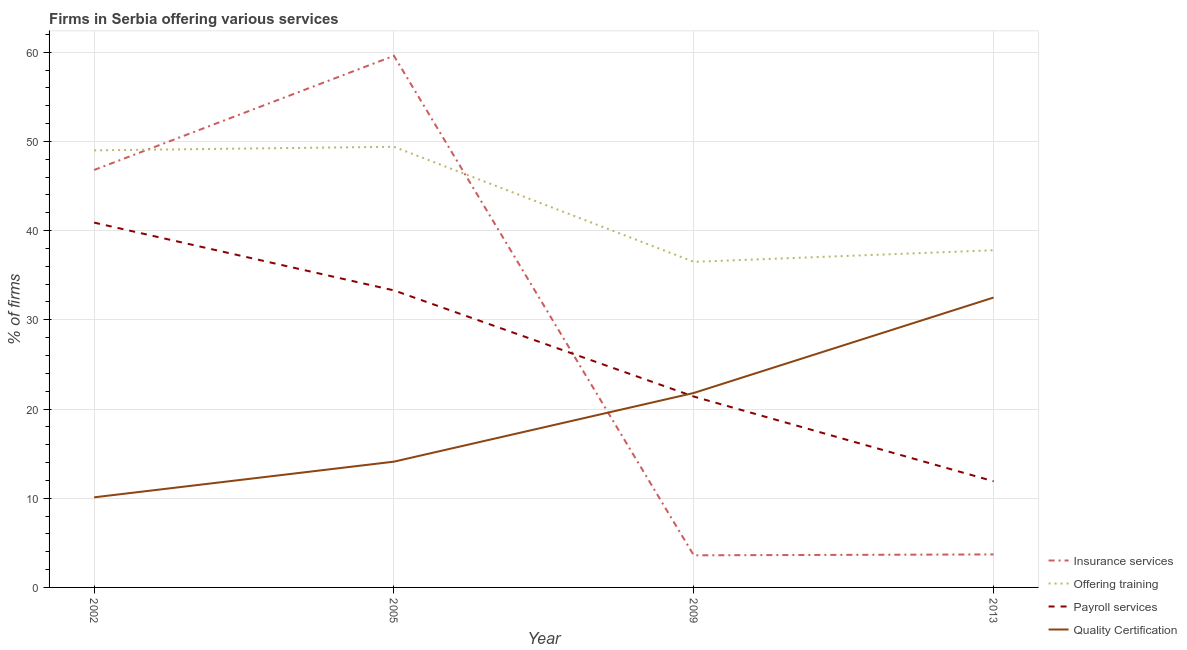Does the line corresponding to percentage of firms offering training intersect with the line corresponding to percentage of firms offering quality certification?
Make the answer very short. No. Across all years, what is the maximum percentage of firms offering training?
Your response must be concise. 49.4. In which year was the percentage of firms offering quality certification maximum?
Make the answer very short. 2013. What is the total percentage of firms offering insurance services in the graph?
Your answer should be very brief. 113.7. What is the difference between the percentage of firms offering insurance services in 2009 and that in 2013?
Your response must be concise. -0.1. What is the difference between the percentage of firms offering training in 2002 and the percentage of firms offering insurance services in 2013?
Keep it short and to the point. 45.3. What is the average percentage of firms offering quality certification per year?
Keep it short and to the point. 19.62. In the year 2002, what is the difference between the percentage of firms offering payroll services and percentage of firms offering training?
Offer a terse response. -8.1. In how many years, is the percentage of firms offering payroll services greater than 58 %?
Your answer should be compact. 0. What is the ratio of the percentage of firms offering insurance services in 2009 to that in 2013?
Offer a very short reply. 0.97. Is the percentage of firms offering insurance services in 2002 less than that in 2013?
Offer a terse response. No. What is the difference between the highest and the second highest percentage of firms offering insurance services?
Keep it short and to the point. 12.8. In how many years, is the percentage of firms offering training greater than the average percentage of firms offering training taken over all years?
Provide a short and direct response. 2. Is the sum of the percentage of firms offering payroll services in 2009 and 2013 greater than the maximum percentage of firms offering training across all years?
Provide a short and direct response. No. Is it the case that in every year, the sum of the percentage of firms offering insurance services and percentage of firms offering training is greater than the percentage of firms offering payroll services?
Offer a terse response. Yes. Is the percentage of firms offering training strictly greater than the percentage of firms offering payroll services over the years?
Ensure brevity in your answer.  Yes. Is the percentage of firms offering payroll services strictly less than the percentage of firms offering training over the years?
Make the answer very short. Yes. Are the values on the major ticks of Y-axis written in scientific E-notation?
Provide a short and direct response. No. Does the graph contain any zero values?
Offer a terse response. No. Where does the legend appear in the graph?
Ensure brevity in your answer.  Bottom right. How many legend labels are there?
Keep it short and to the point. 4. What is the title of the graph?
Offer a very short reply. Firms in Serbia offering various services . What is the label or title of the X-axis?
Provide a short and direct response. Year. What is the label or title of the Y-axis?
Keep it short and to the point. % of firms. What is the % of firms of Insurance services in 2002?
Offer a terse response. 46.8. What is the % of firms of Offering training in 2002?
Ensure brevity in your answer.  49. What is the % of firms of Payroll services in 2002?
Provide a succinct answer. 40.9. What is the % of firms of Quality Certification in 2002?
Ensure brevity in your answer.  10.1. What is the % of firms of Insurance services in 2005?
Give a very brief answer. 59.6. What is the % of firms of Offering training in 2005?
Make the answer very short. 49.4. What is the % of firms of Payroll services in 2005?
Ensure brevity in your answer.  33.3. What is the % of firms in Quality Certification in 2005?
Make the answer very short. 14.1. What is the % of firms of Insurance services in 2009?
Offer a terse response. 3.6. What is the % of firms of Offering training in 2009?
Your response must be concise. 36.5. What is the % of firms in Payroll services in 2009?
Provide a short and direct response. 21.4. What is the % of firms in Quality Certification in 2009?
Keep it short and to the point. 21.8. What is the % of firms in Insurance services in 2013?
Your answer should be compact. 3.7. What is the % of firms in Offering training in 2013?
Ensure brevity in your answer.  37.8. What is the % of firms of Quality Certification in 2013?
Offer a terse response. 32.5. Across all years, what is the maximum % of firms in Insurance services?
Keep it short and to the point. 59.6. Across all years, what is the maximum % of firms in Offering training?
Make the answer very short. 49.4. Across all years, what is the maximum % of firms of Payroll services?
Your answer should be very brief. 40.9. Across all years, what is the maximum % of firms of Quality Certification?
Offer a very short reply. 32.5. Across all years, what is the minimum % of firms in Insurance services?
Make the answer very short. 3.6. Across all years, what is the minimum % of firms of Offering training?
Keep it short and to the point. 36.5. Across all years, what is the minimum % of firms of Payroll services?
Your answer should be very brief. 11.9. What is the total % of firms of Insurance services in the graph?
Your response must be concise. 113.7. What is the total % of firms of Offering training in the graph?
Keep it short and to the point. 172.7. What is the total % of firms of Payroll services in the graph?
Your answer should be compact. 107.5. What is the total % of firms of Quality Certification in the graph?
Make the answer very short. 78.5. What is the difference between the % of firms in Insurance services in 2002 and that in 2005?
Offer a very short reply. -12.8. What is the difference between the % of firms of Payroll services in 2002 and that in 2005?
Provide a short and direct response. 7.6. What is the difference between the % of firms in Quality Certification in 2002 and that in 2005?
Your answer should be compact. -4. What is the difference between the % of firms of Insurance services in 2002 and that in 2009?
Your answer should be very brief. 43.2. What is the difference between the % of firms of Payroll services in 2002 and that in 2009?
Offer a terse response. 19.5. What is the difference between the % of firms of Insurance services in 2002 and that in 2013?
Your response must be concise. 43.1. What is the difference between the % of firms in Offering training in 2002 and that in 2013?
Give a very brief answer. 11.2. What is the difference between the % of firms in Quality Certification in 2002 and that in 2013?
Offer a very short reply. -22.4. What is the difference between the % of firms of Insurance services in 2005 and that in 2009?
Keep it short and to the point. 56. What is the difference between the % of firms of Insurance services in 2005 and that in 2013?
Make the answer very short. 55.9. What is the difference between the % of firms in Offering training in 2005 and that in 2013?
Keep it short and to the point. 11.6. What is the difference between the % of firms in Payroll services in 2005 and that in 2013?
Offer a very short reply. 21.4. What is the difference between the % of firms of Quality Certification in 2005 and that in 2013?
Ensure brevity in your answer.  -18.4. What is the difference between the % of firms in Offering training in 2009 and that in 2013?
Offer a terse response. -1.3. What is the difference between the % of firms in Insurance services in 2002 and the % of firms in Offering training in 2005?
Provide a succinct answer. -2.6. What is the difference between the % of firms in Insurance services in 2002 and the % of firms in Payroll services in 2005?
Offer a very short reply. 13.5. What is the difference between the % of firms of Insurance services in 2002 and the % of firms of Quality Certification in 2005?
Your answer should be very brief. 32.7. What is the difference between the % of firms of Offering training in 2002 and the % of firms of Quality Certification in 2005?
Ensure brevity in your answer.  34.9. What is the difference between the % of firms of Payroll services in 2002 and the % of firms of Quality Certification in 2005?
Give a very brief answer. 26.8. What is the difference between the % of firms in Insurance services in 2002 and the % of firms in Payroll services in 2009?
Your answer should be compact. 25.4. What is the difference between the % of firms in Insurance services in 2002 and the % of firms in Quality Certification in 2009?
Provide a short and direct response. 25. What is the difference between the % of firms in Offering training in 2002 and the % of firms in Payroll services in 2009?
Give a very brief answer. 27.6. What is the difference between the % of firms of Offering training in 2002 and the % of firms of Quality Certification in 2009?
Provide a short and direct response. 27.2. What is the difference between the % of firms of Insurance services in 2002 and the % of firms of Payroll services in 2013?
Keep it short and to the point. 34.9. What is the difference between the % of firms in Offering training in 2002 and the % of firms in Payroll services in 2013?
Ensure brevity in your answer.  37.1. What is the difference between the % of firms of Offering training in 2002 and the % of firms of Quality Certification in 2013?
Make the answer very short. 16.5. What is the difference between the % of firms of Payroll services in 2002 and the % of firms of Quality Certification in 2013?
Provide a short and direct response. 8.4. What is the difference between the % of firms of Insurance services in 2005 and the % of firms of Offering training in 2009?
Your response must be concise. 23.1. What is the difference between the % of firms in Insurance services in 2005 and the % of firms in Payroll services in 2009?
Ensure brevity in your answer.  38.2. What is the difference between the % of firms of Insurance services in 2005 and the % of firms of Quality Certification in 2009?
Offer a very short reply. 37.8. What is the difference between the % of firms of Offering training in 2005 and the % of firms of Payroll services in 2009?
Provide a short and direct response. 28. What is the difference between the % of firms in Offering training in 2005 and the % of firms in Quality Certification in 2009?
Ensure brevity in your answer.  27.6. What is the difference between the % of firms of Insurance services in 2005 and the % of firms of Offering training in 2013?
Keep it short and to the point. 21.8. What is the difference between the % of firms in Insurance services in 2005 and the % of firms in Payroll services in 2013?
Ensure brevity in your answer.  47.7. What is the difference between the % of firms in Insurance services in 2005 and the % of firms in Quality Certification in 2013?
Provide a succinct answer. 27.1. What is the difference between the % of firms in Offering training in 2005 and the % of firms in Payroll services in 2013?
Offer a very short reply. 37.5. What is the difference between the % of firms in Insurance services in 2009 and the % of firms in Offering training in 2013?
Your response must be concise. -34.2. What is the difference between the % of firms in Insurance services in 2009 and the % of firms in Payroll services in 2013?
Keep it short and to the point. -8.3. What is the difference between the % of firms of Insurance services in 2009 and the % of firms of Quality Certification in 2013?
Offer a very short reply. -28.9. What is the difference between the % of firms in Offering training in 2009 and the % of firms in Payroll services in 2013?
Ensure brevity in your answer.  24.6. What is the difference between the % of firms of Payroll services in 2009 and the % of firms of Quality Certification in 2013?
Provide a short and direct response. -11.1. What is the average % of firms in Insurance services per year?
Make the answer very short. 28.43. What is the average % of firms of Offering training per year?
Keep it short and to the point. 43.17. What is the average % of firms in Payroll services per year?
Ensure brevity in your answer.  26.88. What is the average % of firms of Quality Certification per year?
Provide a succinct answer. 19.62. In the year 2002, what is the difference between the % of firms of Insurance services and % of firms of Offering training?
Ensure brevity in your answer.  -2.2. In the year 2002, what is the difference between the % of firms of Insurance services and % of firms of Payroll services?
Give a very brief answer. 5.9. In the year 2002, what is the difference between the % of firms in Insurance services and % of firms in Quality Certification?
Ensure brevity in your answer.  36.7. In the year 2002, what is the difference between the % of firms in Offering training and % of firms in Quality Certification?
Your response must be concise. 38.9. In the year 2002, what is the difference between the % of firms in Payroll services and % of firms in Quality Certification?
Give a very brief answer. 30.8. In the year 2005, what is the difference between the % of firms of Insurance services and % of firms of Offering training?
Make the answer very short. 10.2. In the year 2005, what is the difference between the % of firms in Insurance services and % of firms in Payroll services?
Your response must be concise. 26.3. In the year 2005, what is the difference between the % of firms of Insurance services and % of firms of Quality Certification?
Offer a very short reply. 45.5. In the year 2005, what is the difference between the % of firms in Offering training and % of firms in Payroll services?
Give a very brief answer. 16.1. In the year 2005, what is the difference between the % of firms of Offering training and % of firms of Quality Certification?
Offer a terse response. 35.3. In the year 2009, what is the difference between the % of firms of Insurance services and % of firms of Offering training?
Provide a succinct answer. -32.9. In the year 2009, what is the difference between the % of firms of Insurance services and % of firms of Payroll services?
Your response must be concise. -17.8. In the year 2009, what is the difference between the % of firms in Insurance services and % of firms in Quality Certification?
Keep it short and to the point. -18.2. In the year 2009, what is the difference between the % of firms of Offering training and % of firms of Payroll services?
Give a very brief answer. 15.1. In the year 2013, what is the difference between the % of firms of Insurance services and % of firms of Offering training?
Offer a very short reply. -34.1. In the year 2013, what is the difference between the % of firms of Insurance services and % of firms of Payroll services?
Offer a very short reply. -8.2. In the year 2013, what is the difference between the % of firms in Insurance services and % of firms in Quality Certification?
Make the answer very short. -28.8. In the year 2013, what is the difference between the % of firms of Offering training and % of firms of Payroll services?
Provide a short and direct response. 25.9. In the year 2013, what is the difference between the % of firms in Offering training and % of firms in Quality Certification?
Offer a very short reply. 5.3. In the year 2013, what is the difference between the % of firms in Payroll services and % of firms in Quality Certification?
Make the answer very short. -20.6. What is the ratio of the % of firms in Insurance services in 2002 to that in 2005?
Offer a terse response. 0.79. What is the ratio of the % of firms in Offering training in 2002 to that in 2005?
Your answer should be compact. 0.99. What is the ratio of the % of firms of Payroll services in 2002 to that in 2005?
Your answer should be compact. 1.23. What is the ratio of the % of firms in Quality Certification in 2002 to that in 2005?
Offer a terse response. 0.72. What is the ratio of the % of firms in Insurance services in 2002 to that in 2009?
Offer a very short reply. 13. What is the ratio of the % of firms of Offering training in 2002 to that in 2009?
Give a very brief answer. 1.34. What is the ratio of the % of firms in Payroll services in 2002 to that in 2009?
Offer a terse response. 1.91. What is the ratio of the % of firms of Quality Certification in 2002 to that in 2009?
Provide a short and direct response. 0.46. What is the ratio of the % of firms in Insurance services in 2002 to that in 2013?
Provide a short and direct response. 12.65. What is the ratio of the % of firms in Offering training in 2002 to that in 2013?
Offer a very short reply. 1.3. What is the ratio of the % of firms of Payroll services in 2002 to that in 2013?
Make the answer very short. 3.44. What is the ratio of the % of firms of Quality Certification in 2002 to that in 2013?
Ensure brevity in your answer.  0.31. What is the ratio of the % of firms of Insurance services in 2005 to that in 2009?
Your response must be concise. 16.56. What is the ratio of the % of firms of Offering training in 2005 to that in 2009?
Provide a short and direct response. 1.35. What is the ratio of the % of firms in Payroll services in 2005 to that in 2009?
Make the answer very short. 1.56. What is the ratio of the % of firms of Quality Certification in 2005 to that in 2009?
Your answer should be compact. 0.65. What is the ratio of the % of firms of Insurance services in 2005 to that in 2013?
Your response must be concise. 16.11. What is the ratio of the % of firms in Offering training in 2005 to that in 2013?
Keep it short and to the point. 1.31. What is the ratio of the % of firms of Payroll services in 2005 to that in 2013?
Your response must be concise. 2.8. What is the ratio of the % of firms of Quality Certification in 2005 to that in 2013?
Provide a succinct answer. 0.43. What is the ratio of the % of firms in Offering training in 2009 to that in 2013?
Offer a terse response. 0.97. What is the ratio of the % of firms of Payroll services in 2009 to that in 2013?
Provide a succinct answer. 1.8. What is the ratio of the % of firms of Quality Certification in 2009 to that in 2013?
Give a very brief answer. 0.67. What is the difference between the highest and the second highest % of firms in Insurance services?
Keep it short and to the point. 12.8. What is the difference between the highest and the second highest % of firms of Quality Certification?
Offer a terse response. 10.7. What is the difference between the highest and the lowest % of firms of Insurance services?
Provide a succinct answer. 56. What is the difference between the highest and the lowest % of firms in Offering training?
Give a very brief answer. 12.9. What is the difference between the highest and the lowest % of firms in Quality Certification?
Make the answer very short. 22.4. 